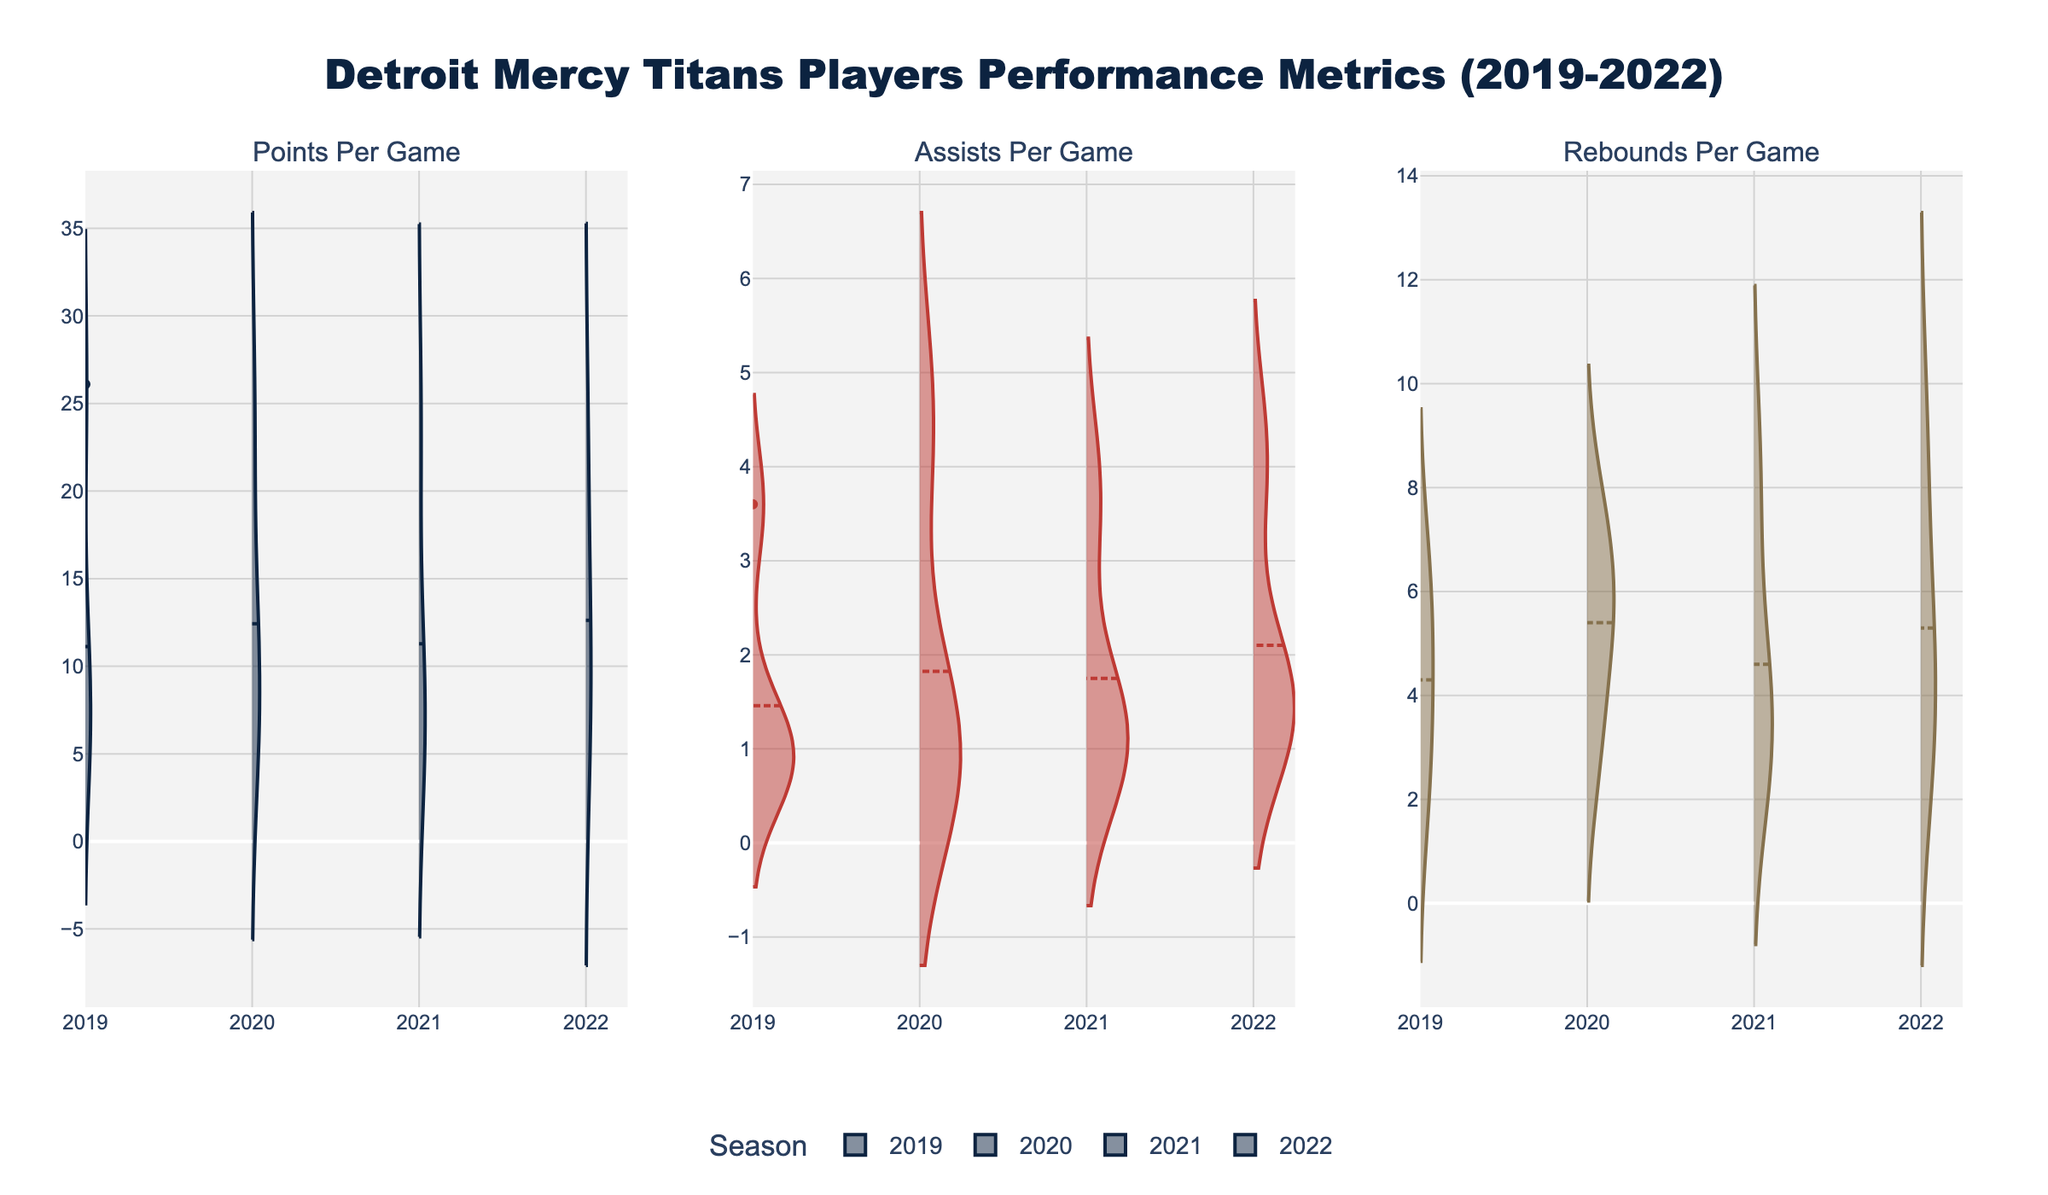What's the title of the figure? The title is usually displayed at the top of the figure. It provides a summary of what the figure is about. In this case, the title reads "Detroit Mercy Titans Players Performance Metrics (2019-2022)."
Answer: Detroit Mercy Titans Players Performance Metrics (2019-2022) Which season has the highest density of Points Per Game around 24? To determine this, we look for the peak of the density plot around the 24 Points Per Game mark. The density plot for the 2020 season shows the highest peak around this value.
Answer: 2020 Which season appears to have the most consistent Assists Per Game values? Consistency can be inferred from the density plot where the values are most concentrated around the mean. The 2021 season shows the most concentrated spread for Assists Per Game.
Answer: 2021 Which season shows the highest mean Rebounds Per Game? Mean values are indicated by a visible line in each density plot. The 2022 season has the highest mean line in the Rebounds Per Game plot.
Answer: 2022 Between 2019 and 2020, which season had a higher median Points Per Game? The median can be inferred from the distribution of values. The 2019 season has a more centered and lower peak compared to the higher central peak of 2020. Thus, 2020 has a higher median.
Answer: 2020 How does the density of Rebounds Per Game differ from 2019 to 2022? Comparing the 2019 and 2022 density plots for Rebounds Per Game reveals that 2022 has a broader and higher peak distribution compared to 2019, indicating an increase in density.
Answer: 2022 has higher density In which metric do players show the biggest change from one season to another? By comparing density plots across all seasons, you'll notice that Rebounds Per Game have a noticeably higher variance from year to year, especially from 2019 to 2022.
Answer: Rebounds Per Game Do Points Per Game show a consistent decline over the seasons? Examining the points per game density plots chronologically reveals that the density peaks shift slightly lower as the seasons progress, indicating a consistent decline.
Answer: Yes Which season has the widest range in any of the performance metrics? The range can be inferred by the spread of the density plot. In the Rebounds Per Game plot, the 2022 season shows the widest distribution from low to high values.
Answer: 2022 How does the distribution of Assists Per Game for 2019 compare to that of Points Per Game for the same year? The comparison can be made by looking at the density plots for both metrics in 2019. Assists Per Game has a narrow distribution while Points Per Game has a much wider spread for 2019.
Answer: Assists Per Game – narrow; Points Per Game – wide 